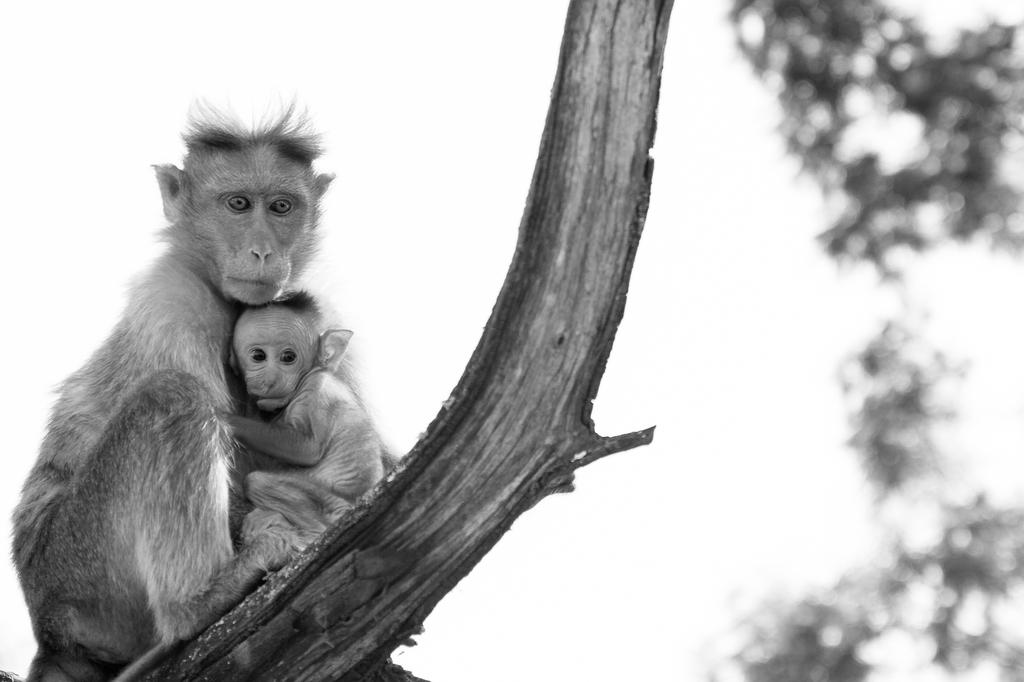What animals are present in the image? There are two monkeys on a branch in the image. What can be seen in the background of the image? The background of the image includes leaves. How would you describe the quality of the background in the image? The background is blurry. What type of apparel are the monkeys wearing in the image? The monkeys in the image are not wearing any apparel. Can you see any houses in the background of the image? There are no houses visible in the image; only leaves are present in the background. 